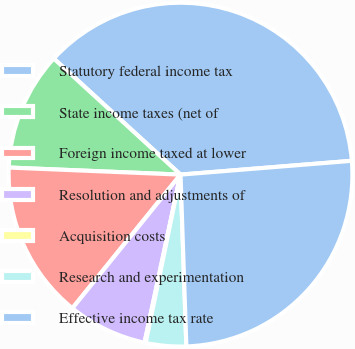Convert chart to OTSL. <chart><loc_0><loc_0><loc_500><loc_500><pie_chart><fcel>Statutory federal income tax<fcel>State income taxes (net of<fcel>Foreign income taxed at lower<fcel>Resolution and adjustments of<fcel>Acquisition costs<fcel>Research and experimentation<fcel>Effective income tax rate<nl><fcel>36.92%<fcel>11.15%<fcel>14.83%<fcel>7.47%<fcel>0.11%<fcel>3.79%<fcel>25.74%<nl></chart> 